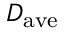Convert formula to latex. <formula><loc_0><loc_0><loc_500><loc_500>D _ { a v e }</formula> 